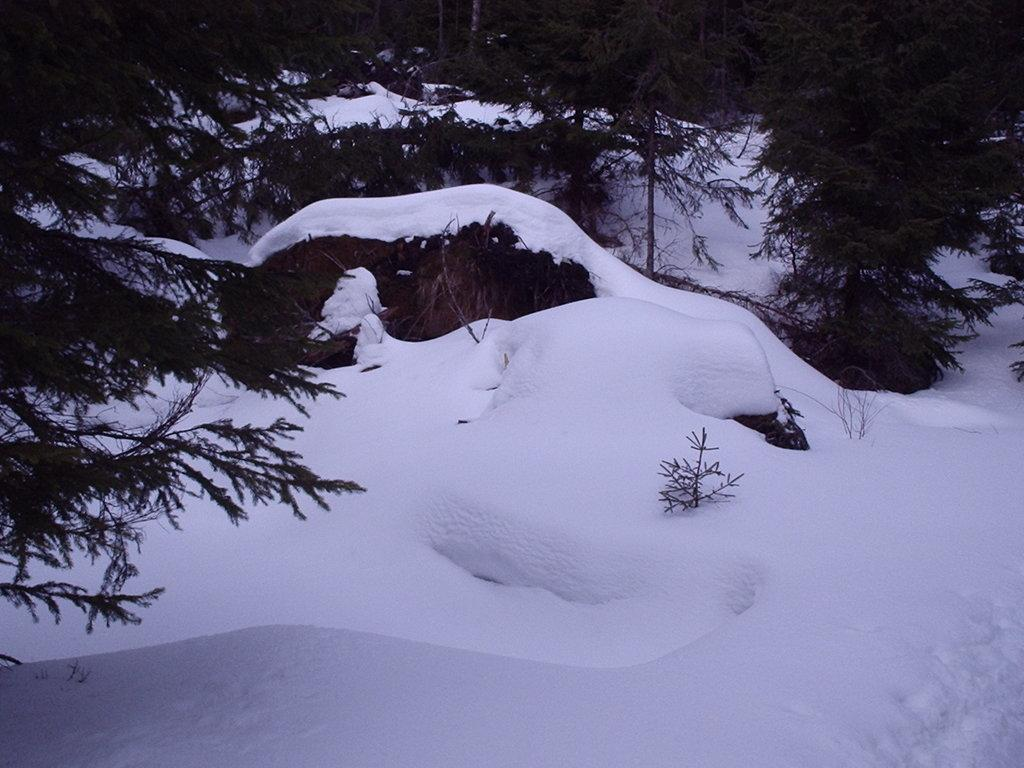What type of weather condition is depicted in the image? There is snow on the ground in the image, indicating a wintery or cold weather condition. What type of vegetation can be seen in the image? Trees are present on the ground in the image. What type of beef is being served in the image? There is no beef present in the image; it features snow on the ground and trees. 